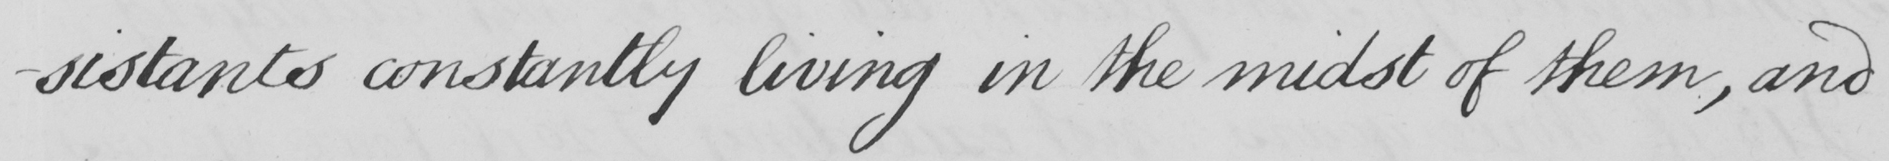Transcribe the text shown in this historical manuscript line. -sistants constantly living in the midst of them , and 